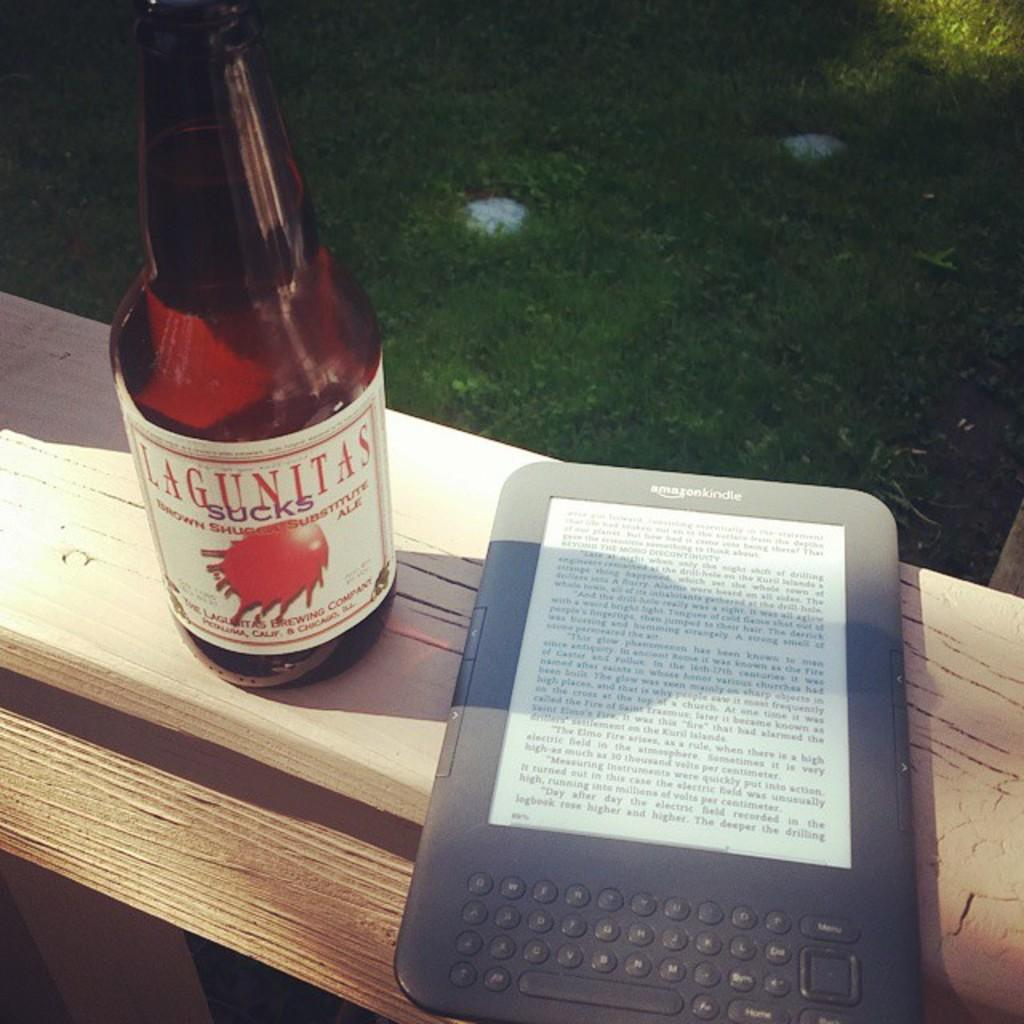<image>
Write a terse but informative summary of the picture. An Amazon Kindle sits on a bench next to a bottle of Lagunitas beer. 